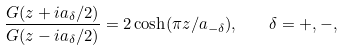Convert formula to latex. <formula><loc_0><loc_0><loc_500><loc_500>\frac { G ( z + i a _ { \delta } / 2 ) } { G ( z - i a _ { \delta } / 2 ) } = 2 \cosh ( \pi z / a _ { - \delta } ) , \quad \delta = + , - ,</formula> 